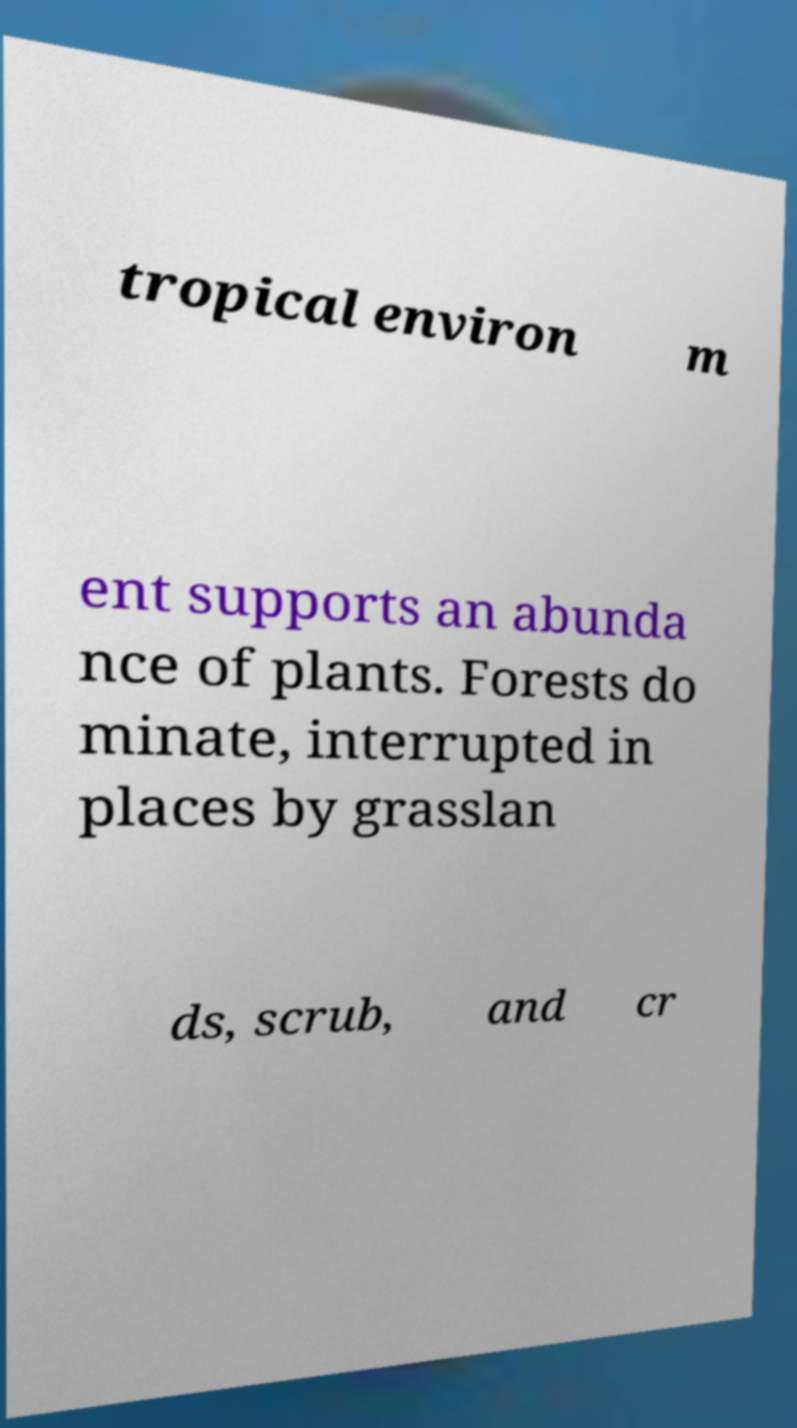I need the written content from this picture converted into text. Can you do that? tropical environ m ent supports an abunda nce of plants. Forests do minate, interrupted in places by grasslan ds, scrub, and cr 